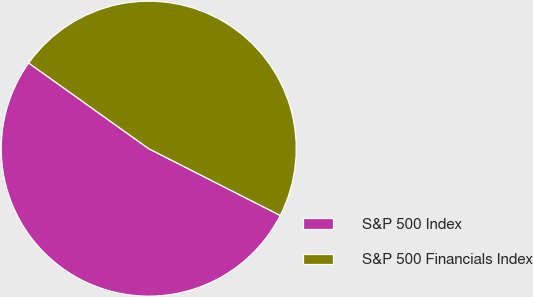<chart> <loc_0><loc_0><loc_500><loc_500><pie_chart><fcel>S&P 500 Index<fcel>S&P 500 Financials Index<nl><fcel>52.39%<fcel>47.61%<nl></chart> 